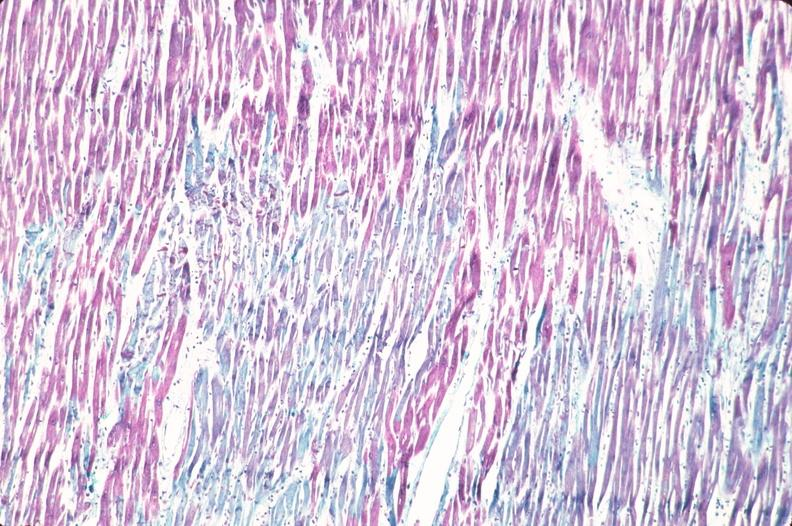what is present?
Answer the question using a single word or phrase. Cardiovascular 